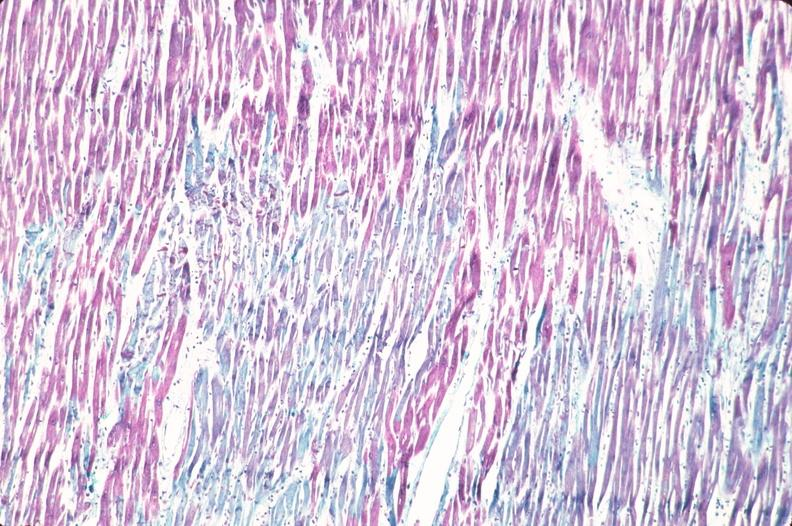what is present?
Answer the question using a single word or phrase. Cardiovascular 